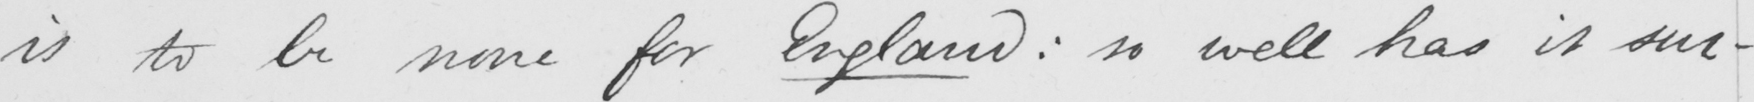What text is written in this handwritten line? is to be none for England :  so well has it suc- 